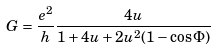<formula> <loc_0><loc_0><loc_500><loc_500>G = \frac { e ^ { 2 } } { h } \frac { 4 u } { 1 + 4 u + 2 u ^ { 2 } ( 1 - \cos { \Phi } ) }</formula> 